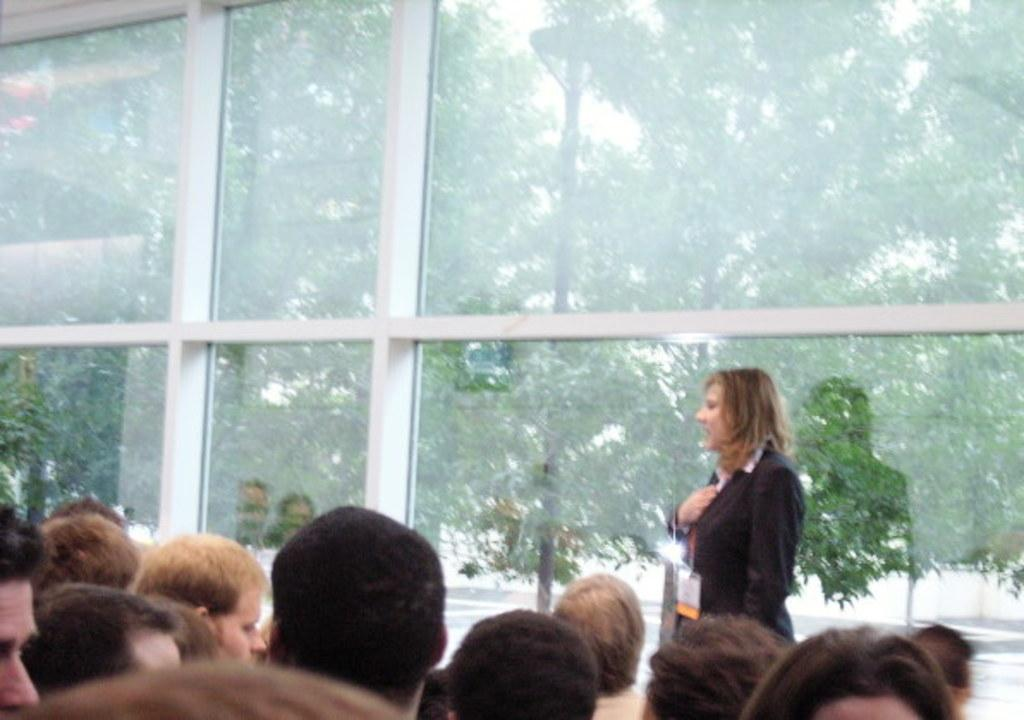Who or what can be seen in the image? There are people in the image. What architectural feature is present in the image? There are windows in the image. What can be seen through the windows? Trees and the sky are visible through the windows. What is a unique aspect of the windows in the image? There are reflections of people on the window glass. What type of wax is being used by the people in the image? There is no wax present in the image, nor is there any indication that the people are using wax for any purpose. 